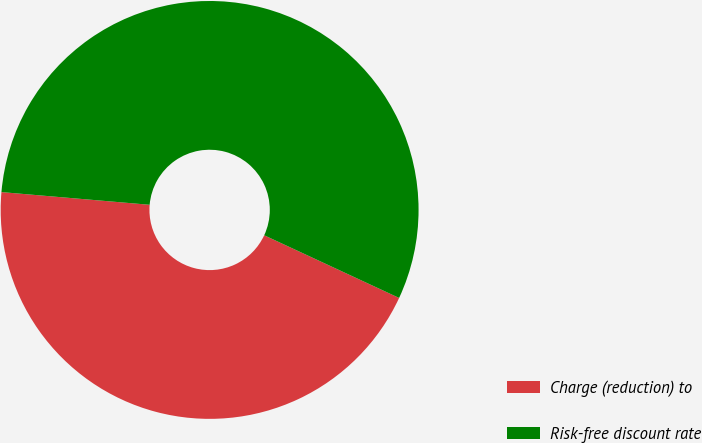Convert chart to OTSL. <chart><loc_0><loc_0><loc_500><loc_500><pie_chart><fcel>Charge (reduction) to<fcel>Risk-free discount rate<nl><fcel>44.44%<fcel>55.56%<nl></chart> 